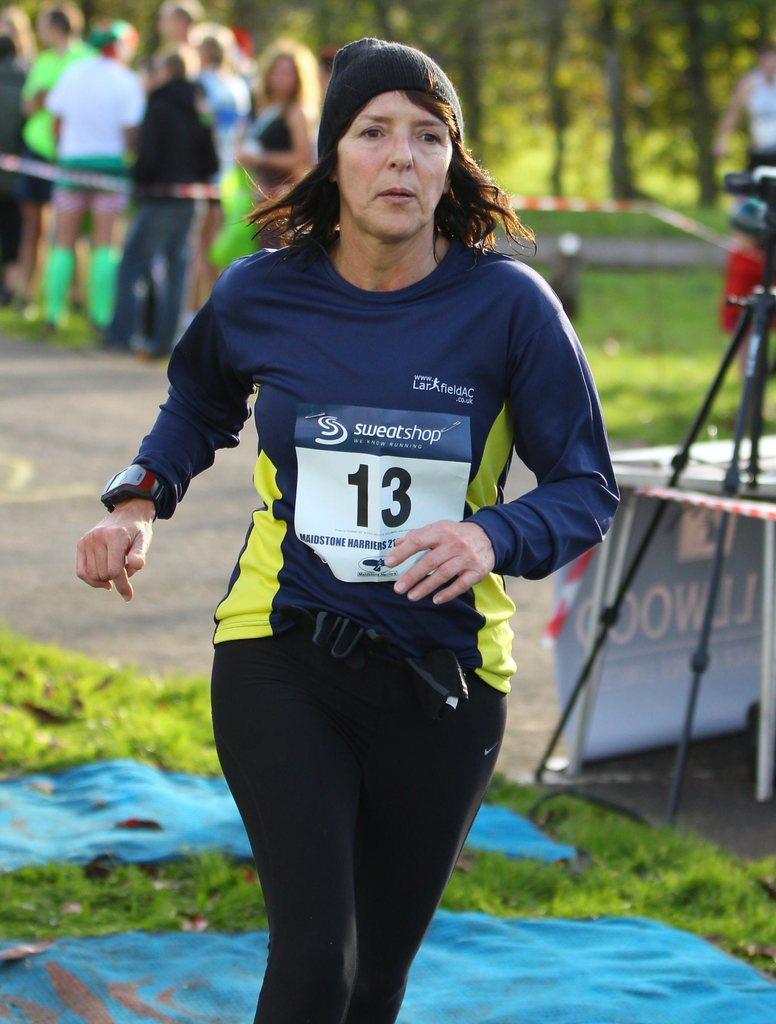Could you give a brief overview of what you see in this image? In the center of the image we can see a woman running. At the bottom there is grass and clothes. On the right we can see a camera placed on the stand. In the background there are people and trees. 